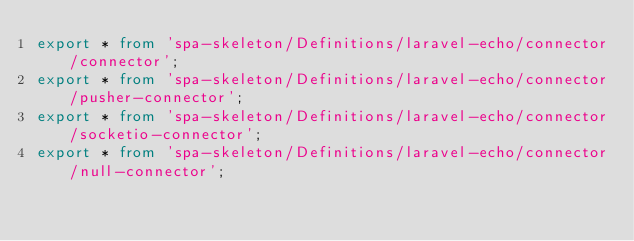Convert code to text. <code><loc_0><loc_0><loc_500><loc_500><_TypeScript_>export * from 'spa-skeleton/Definitions/laravel-echo/connector/connector';
export * from 'spa-skeleton/Definitions/laravel-echo/connector/pusher-connector';
export * from 'spa-skeleton/Definitions/laravel-echo/connector/socketio-connector';
export * from 'spa-skeleton/Definitions/laravel-echo/connector/null-connector';
</code> 